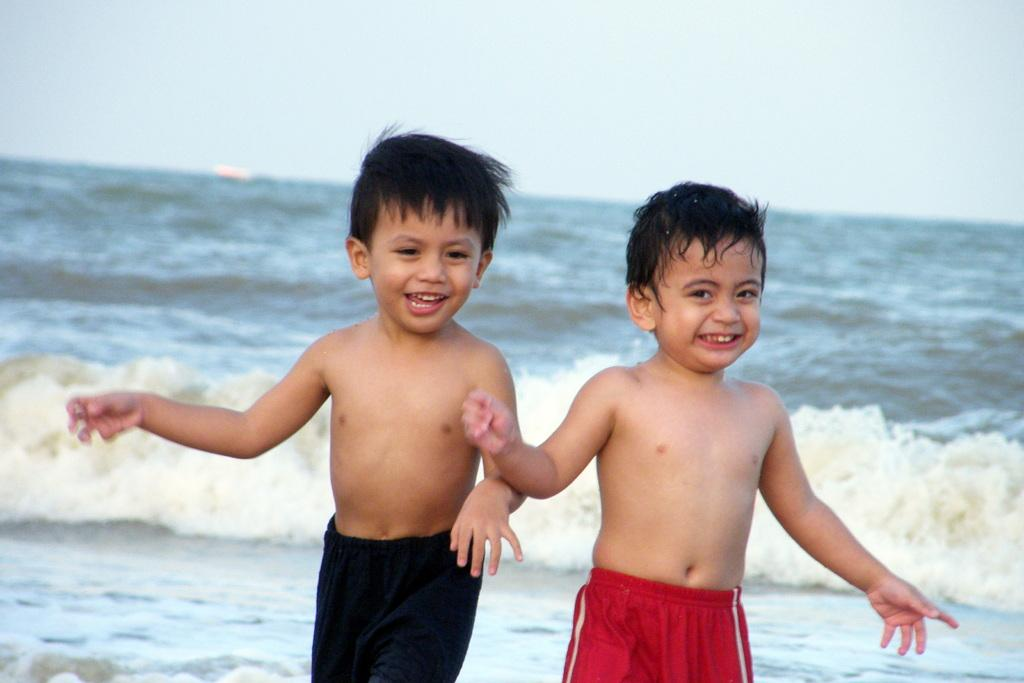How many people are in the image? There are two people in the image. What colors are the dresses worn by the people in the image? One person is wearing a red dress, and the other person is wearing a black dress. What can be seen in the background of the image? Water and the sky are visible in the background of the image. Where is the cap located in the image? There is no cap present in the image. How many sheep can be seen in the image? There are no sheep present in the image. 